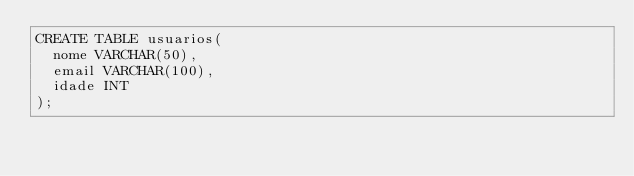<code> <loc_0><loc_0><loc_500><loc_500><_SQL_>CREATE TABLE usuarios(
  nome VARCHAR(50),
  email VARCHAR(100),
  idade INT
);
</code> 